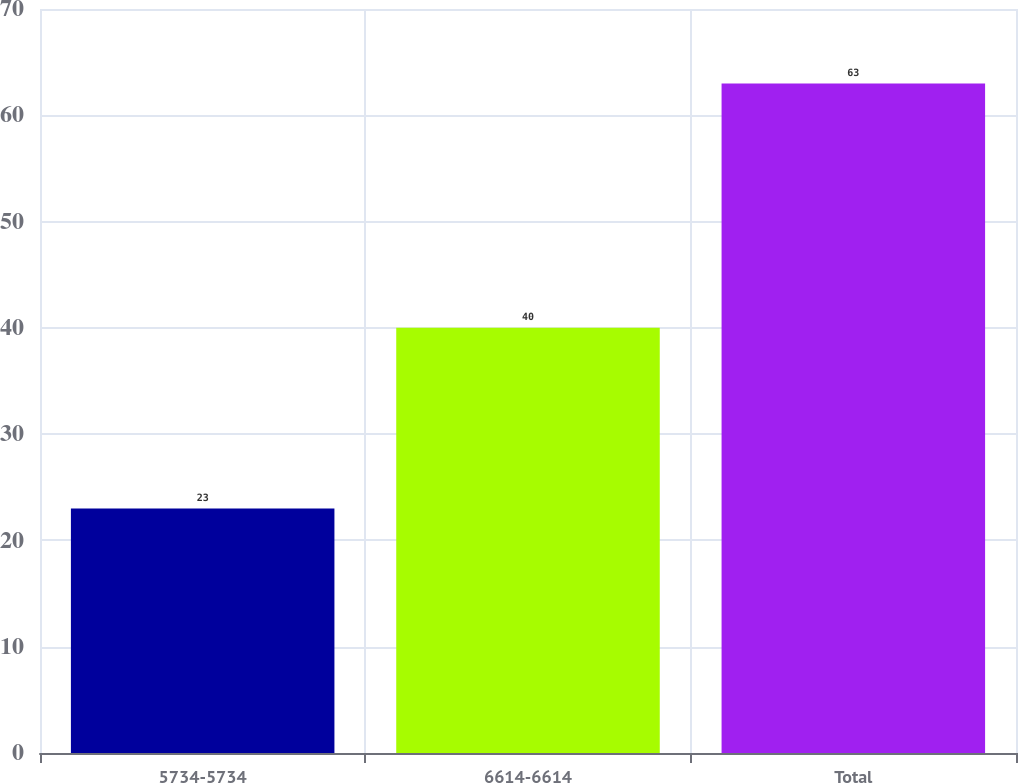<chart> <loc_0><loc_0><loc_500><loc_500><bar_chart><fcel>5734-5734<fcel>6614-6614<fcel>Total<nl><fcel>23<fcel>40<fcel>63<nl></chart> 